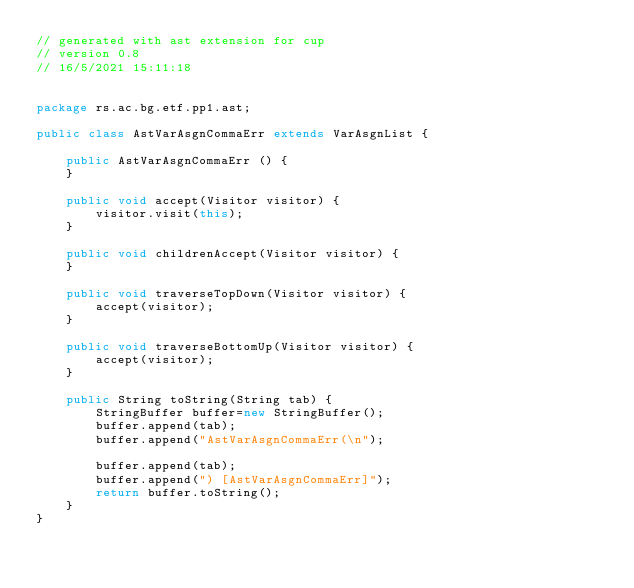Convert code to text. <code><loc_0><loc_0><loc_500><loc_500><_Java_>// generated with ast extension for cup
// version 0.8
// 16/5/2021 15:11:18


package rs.ac.bg.etf.pp1.ast;

public class AstVarAsgnCommaErr extends VarAsgnList {

    public AstVarAsgnCommaErr () {
    }

    public void accept(Visitor visitor) {
        visitor.visit(this);
    }

    public void childrenAccept(Visitor visitor) {
    }

    public void traverseTopDown(Visitor visitor) {
        accept(visitor);
    }

    public void traverseBottomUp(Visitor visitor) {
        accept(visitor);
    }

    public String toString(String tab) {
        StringBuffer buffer=new StringBuffer();
        buffer.append(tab);
        buffer.append("AstVarAsgnCommaErr(\n");

        buffer.append(tab);
        buffer.append(") [AstVarAsgnCommaErr]");
        return buffer.toString();
    }
}
</code> 